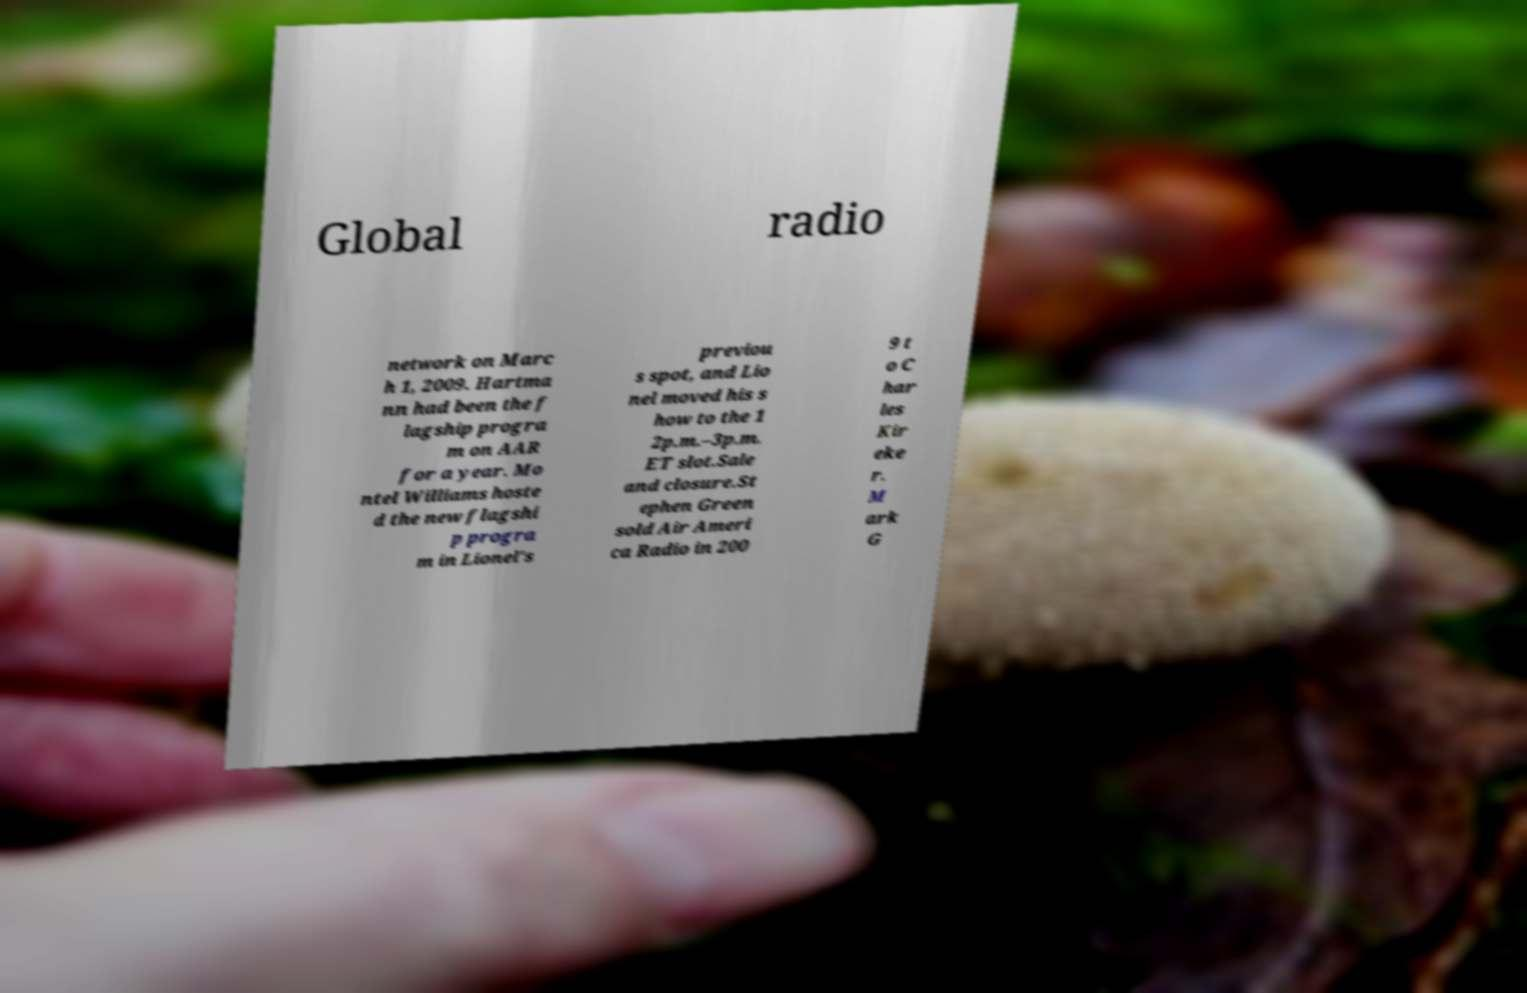Could you assist in decoding the text presented in this image and type it out clearly? Global radio network on Marc h 1, 2009. Hartma nn had been the f lagship progra m on AAR for a year. Mo ntel Williams hoste d the new flagshi p progra m in Lionel's previou s spot, and Lio nel moved his s how to the 1 2p.m.–3p.m. ET slot.Sale and closure.St ephen Green sold Air Ameri ca Radio in 200 9 t o C har les Kir eke r. M ark G 